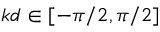Convert formula to latex. <formula><loc_0><loc_0><loc_500><loc_500>k d \in [ - \pi / 2 , \pi / 2 ]</formula> 